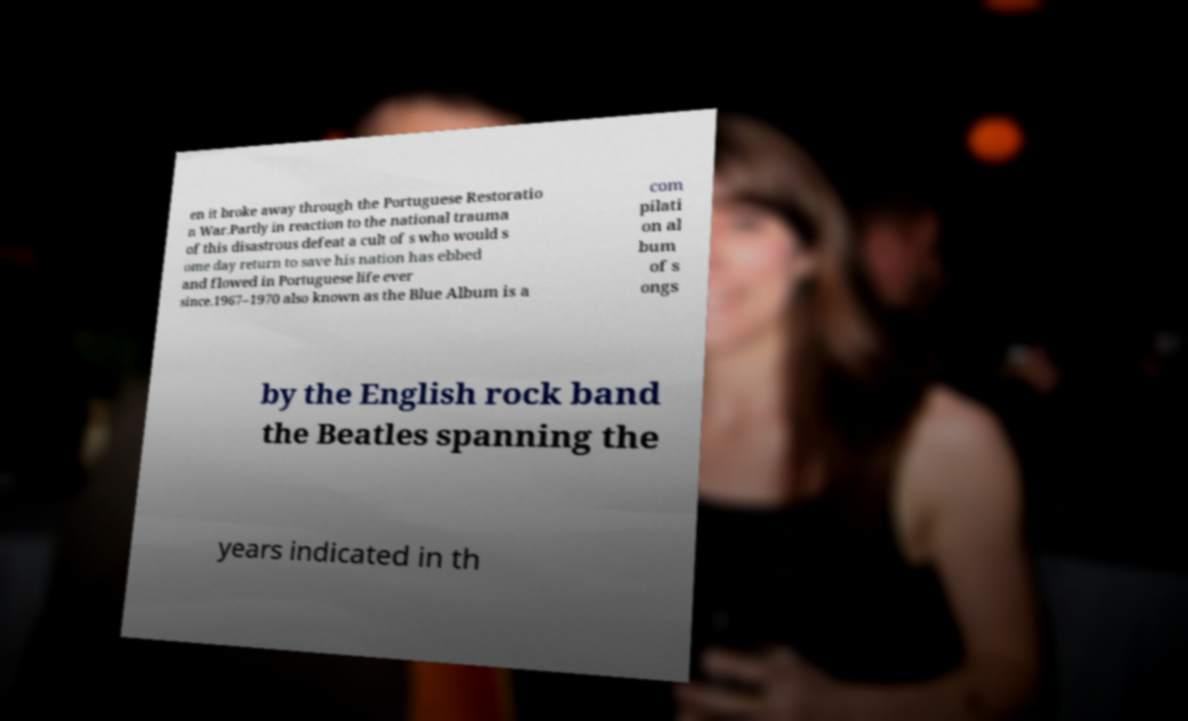Can you read and provide the text displayed in the image?This photo seems to have some interesting text. Can you extract and type it out for me? en it broke away through the Portuguese Restoratio n War.Partly in reaction to the national trauma of this disastrous defeat a cult of s who would s ome day return to save his nation has ebbed and flowed in Portuguese life ever since.1967–1970 also known as the Blue Album is a com pilati on al bum of s ongs by the English rock band the Beatles spanning the years indicated in th 